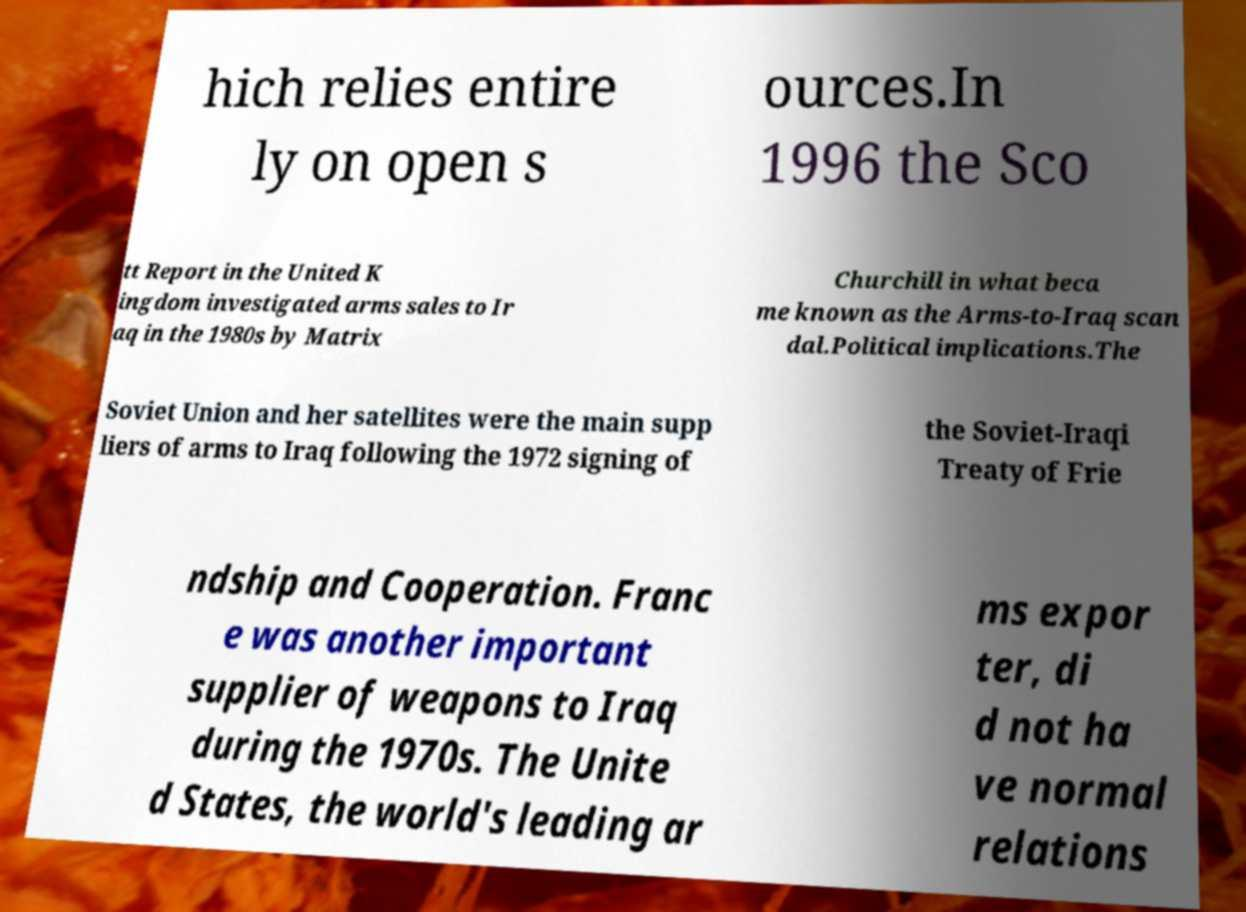What messages or text are displayed in this image? I need them in a readable, typed format. hich relies entire ly on open s ources.In 1996 the Sco tt Report in the United K ingdom investigated arms sales to Ir aq in the 1980s by Matrix Churchill in what beca me known as the Arms-to-Iraq scan dal.Political implications.The Soviet Union and her satellites were the main supp liers of arms to Iraq following the 1972 signing of the Soviet-Iraqi Treaty of Frie ndship and Cooperation. Franc e was another important supplier of weapons to Iraq during the 1970s. The Unite d States, the world's leading ar ms expor ter, di d not ha ve normal relations 